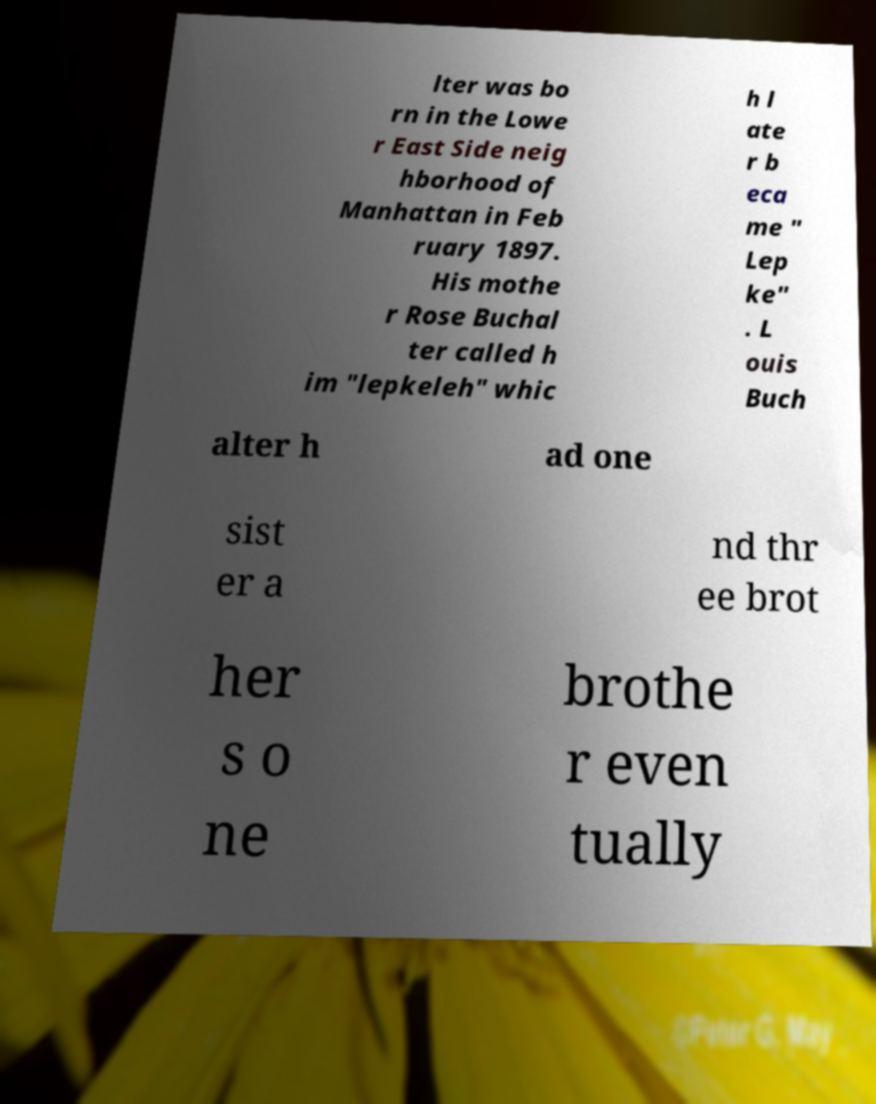For documentation purposes, I need the text within this image transcribed. Could you provide that? lter was bo rn in the Lowe r East Side neig hborhood of Manhattan in Feb ruary 1897. His mothe r Rose Buchal ter called h im "lepkeleh" whic h l ate r b eca me " Lep ke" . L ouis Buch alter h ad one sist er a nd thr ee brot her s o ne brothe r even tually 